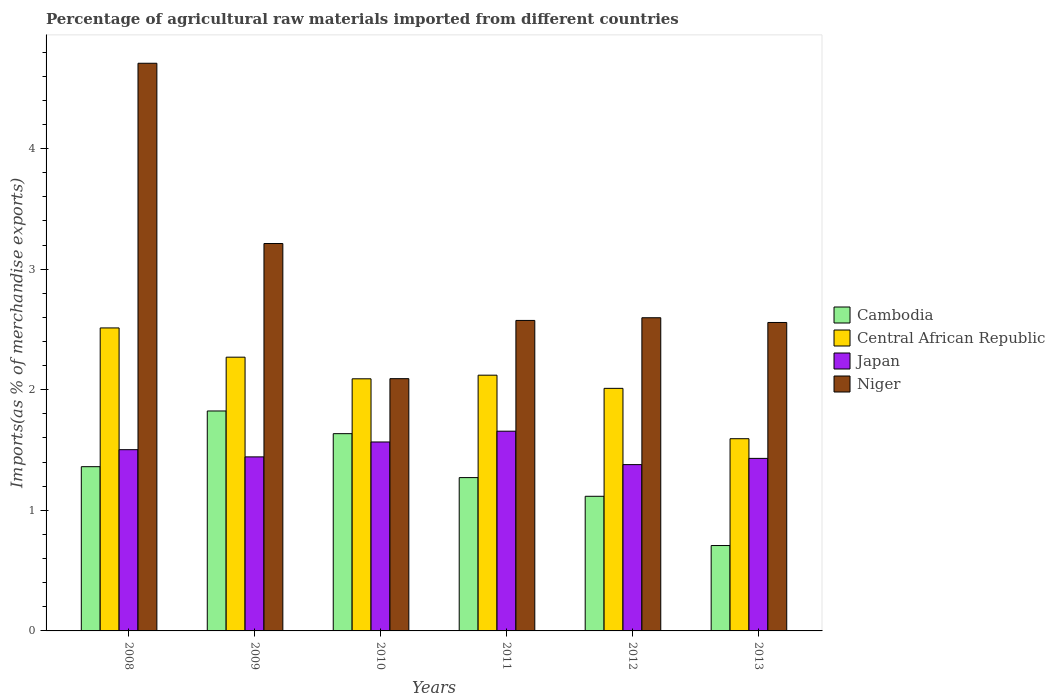How many groups of bars are there?
Provide a short and direct response. 6. Are the number of bars on each tick of the X-axis equal?
Give a very brief answer. Yes. How many bars are there on the 4th tick from the left?
Make the answer very short. 4. In how many cases, is the number of bars for a given year not equal to the number of legend labels?
Provide a short and direct response. 0. What is the percentage of imports to different countries in Cambodia in 2013?
Provide a succinct answer. 0.71. Across all years, what is the maximum percentage of imports to different countries in Central African Republic?
Offer a terse response. 2.51. Across all years, what is the minimum percentage of imports to different countries in Cambodia?
Offer a very short reply. 0.71. In which year was the percentage of imports to different countries in Cambodia maximum?
Offer a terse response. 2009. In which year was the percentage of imports to different countries in Japan minimum?
Keep it short and to the point. 2012. What is the total percentage of imports to different countries in Japan in the graph?
Offer a terse response. 8.98. What is the difference between the percentage of imports to different countries in Japan in 2009 and that in 2011?
Offer a very short reply. -0.21. What is the difference between the percentage of imports to different countries in Niger in 2010 and the percentage of imports to different countries in Central African Republic in 2009?
Your answer should be compact. -0.18. What is the average percentage of imports to different countries in Niger per year?
Keep it short and to the point. 2.96. In the year 2009, what is the difference between the percentage of imports to different countries in Cambodia and percentage of imports to different countries in Japan?
Offer a very short reply. 0.38. In how many years, is the percentage of imports to different countries in Central African Republic greater than 3.8 %?
Ensure brevity in your answer.  0. What is the ratio of the percentage of imports to different countries in Central African Republic in 2010 to that in 2011?
Your answer should be very brief. 0.99. Is the difference between the percentage of imports to different countries in Cambodia in 2010 and 2011 greater than the difference between the percentage of imports to different countries in Japan in 2010 and 2011?
Offer a very short reply. Yes. What is the difference between the highest and the second highest percentage of imports to different countries in Central African Republic?
Your response must be concise. 0.24. What is the difference between the highest and the lowest percentage of imports to different countries in Japan?
Give a very brief answer. 0.28. What does the 2nd bar from the left in 2009 represents?
Offer a very short reply. Central African Republic. Is it the case that in every year, the sum of the percentage of imports to different countries in Niger and percentage of imports to different countries in Japan is greater than the percentage of imports to different countries in Cambodia?
Your answer should be compact. Yes. What is the difference between two consecutive major ticks on the Y-axis?
Ensure brevity in your answer.  1. Are the values on the major ticks of Y-axis written in scientific E-notation?
Provide a short and direct response. No. How are the legend labels stacked?
Your response must be concise. Vertical. What is the title of the graph?
Make the answer very short. Percentage of agricultural raw materials imported from different countries. Does "Micronesia" appear as one of the legend labels in the graph?
Your answer should be very brief. No. What is the label or title of the Y-axis?
Offer a very short reply. Imports(as % of merchandise exports). What is the Imports(as % of merchandise exports) of Cambodia in 2008?
Provide a succinct answer. 1.36. What is the Imports(as % of merchandise exports) of Central African Republic in 2008?
Give a very brief answer. 2.51. What is the Imports(as % of merchandise exports) of Japan in 2008?
Your response must be concise. 1.5. What is the Imports(as % of merchandise exports) of Niger in 2008?
Provide a short and direct response. 4.71. What is the Imports(as % of merchandise exports) in Cambodia in 2009?
Ensure brevity in your answer.  1.82. What is the Imports(as % of merchandise exports) of Central African Republic in 2009?
Offer a very short reply. 2.27. What is the Imports(as % of merchandise exports) of Japan in 2009?
Your answer should be compact. 1.44. What is the Imports(as % of merchandise exports) of Niger in 2009?
Provide a short and direct response. 3.21. What is the Imports(as % of merchandise exports) of Cambodia in 2010?
Ensure brevity in your answer.  1.64. What is the Imports(as % of merchandise exports) of Central African Republic in 2010?
Keep it short and to the point. 2.09. What is the Imports(as % of merchandise exports) of Japan in 2010?
Keep it short and to the point. 1.57. What is the Imports(as % of merchandise exports) in Niger in 2010?
Offer a terse response. 2.09. What is the Imports(as % of merchandise exports) of Cambodia in 2011?
Provide a short and direct response. 1.27. What is the Imports(as % of merchandise exports) in Central African Republic in 2011?
Make the answer very short. 2.12. What is the Imports(as % of merchandise exports) in Japan in 2011?
Your answer should be very brief. 1.66. What is the Imports(as % of merchandise exports) of Niger in 2011?
Provide a succinct answer. 2.57. What is the Imports(as % of merchandise exports) in Cambodia in 2012?
Make the answer very short. 1.12. What is the Imports(as % of merchandise exports) in Central African Republic in 2012?
Your response must be concise. 2.01. What is the Imports(as % of merchandise exports) in Japan in 2012?
Your response must be concise. 1.38. What is the Imports(as % of merchandise exports) of Niger in 2012?
Your answer should be very brief. 2.6. What is the Imports(as % of merchandise exports) in Cambodia in 2013?
Your answer should be very brief. 0.71. What is the Imports(as % of merchandise exports) of Central African Republic in 2013?
Give a very brief answer. 1.59. What is the Imports(as % of merchandise exports) in Japan in 2013?
Provide a succinct answer. 1.43. What is the Imports(as % of merchandise exports) in Niger in 2013?
Offer a terse response. 2.56. Across all years, what is the maximum Imports(as % of merchandise exports) of Cambodia?
Provide a short and direct response. 1.82. Across all years, what is the maximum Imports(as % of merchandise exports) in Central African Republic?
Ensure brevity in your answer.  2.51. Across all years, what is the maximum Imports(as % of merchandise exports) of Japan?
Provide a succinct answer. 1.66. Across all years, what is the maximum Imports(as % of merchandise exports) in Niger?
Ensure brevity in your answer.  4.71. Across all years, what is the minimum Imports(as % of merchandise exports) in Cambodia?
Ensure brevity in your answer.  0.71. Across all years, what is the minimum Imports(as % of merchandise exports) in Central African Republic?
Provide a succinct answer. 1.59. Across all years, what is the minimum Imports(as % of merchandise exports) in Japan?
Keep it short and to the point. 1.38. Across all years, what is the minimum Imports(as % of merchandise exports) of Niger?
Provide a short and direct response. 2.09. What is the total Imports(as % of merchandise exports) in Cambodia in the graph?
Your answer should be very brief. 7.92. What is the total Imports(as % of merchandise exports) of Central African Republic in the graph?
Your answer should be compact. 12.6. What is the total Imports(as % of merchandise exports) in Japan in the graph?
Offer a terse response. 8.98. What is the total Imports(as % of merchandise exports) in Niger in the graph?
Provide a short and direct response. 17.74. What is the difference between the Imports(as % of merchandise exports) in Cambodia in 2008 and that in 2009?
Ensure brevity in your answer.  -0.46. What is the difference between the Imports(as % of merchandise exports) in Central African Republic in 2008 and that in 2009?
Your answer should be very brief. 0.24. What is the difference between the Imports(as % of merchandise exports) of Japan in 2008 and that in 2009?
Ensure brevity in your answer.  0.06. What is the difference between the Imports(as % of merchandise exports) in Niger in 2008 and that in 2009?
Offer a terse response. 1.49. What is the difference between the Imports(as % of merchandise exports) of Cambodia in 2008 and that in 2010?
Your answer should be compact. -0.27. What is the difference between the Imports(as % of merchandise exports) in Central African Republic in 2008 and that in 2010?
Offer a terse response. 0.42. What is the difference between the Imports(as % of merchandise exports) of Japan in 2008 and that in 2010?
Provide a succinct answer. -0.06. What is the difference between the Imports(as % of merchandise exports) of Niger in 2008 and that in 2010?
Your answer should be very brief. 2.62. What is the difference between the Imports(as % of merchandise exports) of Cambodia in 2008 and that in 2011?
Your answer should be compact. 0.09. What is the difference between the Imports(as % of merchandise exports) in Central African Republic in 2008 and that in 2011?
Make the answer very short. 0.39. What is the difference between the Imports(as % of merchandise exports) in Japan in 2008 and that in 2011?
Ensure brevity in your answer.  -0.15. What is the difference between the Imports(as % of merchandise exports) in Niger in 2008 and that in 2011?
Your response must be concise. 2.13. What is the difference between the Imports(as % of merchandise exports) of Cambodia in 2008 and that in 2012?
Make the answer very short. 0.25. What is the difference between the Imports(as % of merchandise exports) in Central African Republic in 2008 and that in 2012?
Give a very brief answer. 0.5. What is the difference between the Imports(as % of merchandise exports) of Japan in 2008 and that in 2012?
Your answer should be very brief. 0.12. What is the difference between the Imports(as % of merchandise exports) in Niger in 2008 and that in 2012?
Provide a short and direct response. 2.11. What is the difference between the Imports(as % of merchandise exports) in Cambodia in 2008 and that in 2013?
Your response must be concise. 0.65. What is the difference between the Imports(as % of merchandise exports) of Central African Republic in 2008 and that in 2013?
Provide a succinct answer. 0.92. What is the difference between the Imports(as % of merchandise exports) in Japan in 2008 and that in 2013?
Your answer should be very brief. 0.07. What is the difference between the Imports(as % of merchandise exports) of Niger in 2008 and that in 2013?
Provide a succinct answer. 2.15. What is the difference between the Imports(as % of merchandise exports) of Cambodia in 2009 and that in 2010?
Offer a very short reply. 0.19. What is the difference between the Imports(as % of merchandise exports) in Central African Republic in 2009 and that in 2010?
Keep it short and to the point. 0.18. What is the difference between the Imports(as % of merchandise exports) in Japan in 2009 and that in 2010?
Ensure brevity in your answer.  -0.12. What is the difference between the Imports(as % of merchandise exports) of Niger in 2009 and that in 2010?
Ensure brevity in your answer.  1.12. What is the difference between the Imports(as % of merchandise exports) of Cambodia in 2009 and that in 2011?
Your answer should be compact. 0.55. What is the difference between the Imports(as % of merchandise exports) of Central African Republic in 2009 and that in 2011?
Provide a succinct answer. 0.15. What is the difference between the Imports(as % of merchandise exports) in Japan in 2009 and that in 2011?
Provide a succinct answer. -0.21. What is the difference between the Imports(as % of merchandise exports) in Niger in 2009 and that in 2011?
Offer a very short reply. 0.64. What is the difference between the Imports(as % of merchandise exports) of Cambodia in 2009 and that in 2012?
Provide a short and direct response. 0.71. What is the difference between the Imports(as % of merchandise exports) in Central African Republic in 2009 and that in 2012?
Offer a terse response. 0.26. What is the difference between the Imports(as % of merchandise exports) in Japan in 2009 and that in 2012?
Your answer should be compact. 0.06. What is the difference between the Imports(as % of merchandise exports) in Niger in 2009 and that in 2012?
Provide a succinct answer. 0.62. What is the difference between the Imports(as % of merchandise exports) of Cambodia in 2009 and that in 2013?
Your answer should be compact. 1.12. What is the difference between the Imports(as % of merchandise exports) of Central African Republic in 2009 and that in 2013?
Your answer should be compact. 0.68. What is the difference between the Imports(as % of merchandise exports) in Japan in 2009 and that in 2013?
Your answer should be compact. 0.01. What is the difference between the Imports(as % of merchandise exports) of Niger in 2009 and that in 2013?
Offer a very short reply. 0.65. What is the difference between the Imports(as % of merchandise exports) in Cambodia in 2010 and that in 2011?
Keep it short and to the point. 0.36. What is the difference between the Imports(as % of merchandise exports) in Central African Republic in 2010 and that in 2011?
Provide a short and direct response. -0.03. What is the difference between the Imports(as % of merchandise exports) of Japan in 2010 and that in 2011?
Your answer should be compact. -0.09. What is the difference between the Imports(as % of merchandise exports) in Niger in 2010 and that in 2011?
Offer a terse response. -0.48. What is the difference between the Imports(as % of merchandise exports) in Cambodia in 2010 and that in 2012?
Give a very brief answer. 0.52. What is the difference between the Imports(as % of merchandise exports) of Central African Republic in 2010 and that in 2012?
Offer a very short reply. 0.08. What is the difference between the Imports(as % of merchandise exports) of Japan in 2010 and that in 2012?
Your response must be concise. 0.19. What is the difference between the Imports(as % of merchandise exports) of Niger in 2010 and that in 2012?
Make the answer very short. -0.51. What is the difference between the Imports(as % of merchandise exports) in Cambodia in 2010 and that in 2013?
Offer a terse response. 0.93. What is the difference between the Imports(as % of merchandise exports) in Central African Republic in 2010 and that in 2013?
Ensure brevity in your answer.  0.5. What is the difference between the Imports(as % of merchandise exports) of Japan in 2010 and that in 2013?
Provide a succinct answer. 0.14. What is the difference between the Imports(as % of merchandise exports) of Niger in 2010 and that in 2013?
Ensure brevity in your answer.  -0.47. What is the difference between the Imports(as % of merchandise exports) of Cambodia in 2011 and that in 2012?
Your answer should be compact. 0.15. What is the difference between the Imports(as % of merchandise exports) in Central African Republic in 2011 and that in 2012?
Your answer should be compact. 0.11. What is the difference between the Imports(as % of merchandise exports) of Japan in 2011 and that in 2012?
Provide a succinct answer. 0.28. What is the difference between the Imports(as % of merchandise exports) of Niger in 2011 and that in 2012?
Ensure brevity in your answer.  -0.02. What is the difference between the Imports(as % of merchandise exports) in Cambodia in 2011 and that in 2013?
Your answer should be very brief. 0.56. What is the difference between the Imports(as % of merchandise exports) of Central African Republic in 2011 and that in 2013?
Ensure brevity in your answer.  0.53. What is the difference between the Imports(as % of merchandise exports) of Japan in 2011 and that in 2013?
Provide a succinct answer. 0.23. What is the difference between the Imports(as % of merchandise exports) in Niger in 2011 and that in 2013?
Your answer should be very brief. 0.02. What is the difference between the Imports(as % of merchandise exports) of Cambodia in 2012 and that in 2013?
Provide a succinct answer. 0.41. What is the difference between the Imports(as % of merchandise exports) in Central African Republic in 2012 and that in 2013?
Keep it short and to the point. 0.42. What is the difference between the Imports(as % of merchandise exports) of Japan in 2012 and that in 2013?
Ensure brevity in your answer.  -0.05. What is the difference between the Imports(as % of merchandise exports) in Niger in 2012 and that in 2013?
Your response must be concise. 0.04. What is the difference between the Imports(as % of merchandise exports) of Cambodia in 2008 and the Imports(as % of merchandise exports) of Central African Republic in 2009?
Make the answer very short. -0.91. What is the difference between the Imports(as % of merchandise exports) of Cambodia in 2008 and the Imports(as % of merchandise exports) of Japan in 2009?
Your answer should be compact. -0.08. What is the difference between the Imports(as % of merchandise exports) of Cambodia in 2008 and the Imports(as % of merchandise exports) of Niger in 2009?
Offer a terse response. -1.85. What is the difference between the Imports(as % of merchandise exports) of Central African Republic in 2008 and the Imports(as % of merchandise exports) of Japan in 2009?
Your answer should be compact. 1.07. What is the difference between the Imports(as % of merchandise exports) in Central African Republic in 2008 and the Imports(as % of merchandise exports) in Niger in 2009?
Ensure brevity in your answer.  -0.7. What is the difference between the Imports(as % of merchandise exports) of Japan in 2008 and the Imports(as % of merchandise exports) of Niger in 2009?
Give a very brief answer. -1.71. What is the difference between the Imports(as % of merchandise exports) in Cambodia in 2008 and the Imports(as % of merchandise exports) in Central African Republic in 2010?
Ensure brevity in your answer.  -0.73. What is the difference between the Imports(as % of merchandise exports) of Cambodia in 2008 and the Imports(as % of merchandise exports) of Japan in 2010?
Your response must be concise. -0.2. What is the difference between the Imports(as % of merchandise exports) in Cambodia in 2008 and the Imports(as % of merchandise exports) in Niger in 2010?
Your answer should be compact. -0.73. What is the difference between the Imports(as % of merchandise exports) of Central African Republic in 2008 and the Imports(as % of merchandise exports) of Japan in 2010?
Ensure brevity in your answer.  0.95. What is the difference between the Imports(as % of merchandise exports) in Central African Republic in 2008 and the Imports(as % of merchandise exports) in Niger in 2010?
Your response must be concise. 0.42. What is the difference between the Imports(as % of merchandise exports) in Japan in 2008 and the Imports(as % of merchandise exports) in Niger in 2010?
Make the answer very short. -0.59. What is the difference between the Imports(as % of merchandise exports) in Cambodia in 2008 and the Imports(as % of merchandise exports) in Central African Republic in 2011?
Your answer should be very brief. -0.76. What is the difference between the Imports(as % of merchandise exports) of Cambodia in 2008 and the Imports(as % of merchandise exports) of Japan in 2011?
Make the answer very short. -0.29. What is the difference between the Imports(as % of merchandise exports) in Cambodia in 2008 and the Imports(as % of merchandise exports) in Niger in 2011?
Provide a succinct answer. -1.21. What is the difference between the Imports(as % of merchandise exports) in Central African Republic in 2008 and the Imports(as % of merchandise exports) in Japan in 2011?
Offer a terse response. 0.86. What is the difference between the Imports(as % of merchandise exports) of Central African Republic in 2008 and the Imports(as % of merchandise exports) of Niger in 2011?
Ensure brevity in your answer.  -0.06. What is the difference between the Imports(as % of merchandise exports) in Japan in 2008 and the Imports(as % of merchandise exports) in Niger in 2011?
Offer a very short reply. -1.07. What is the difference between the Imports(as % of merchandise exports) in Cambodia in 2008 and the Imports(as % of merchandise exports) in Central African Republic in 2012?
Ensure brevity in your answer.  -0.65. What is the difference between the Imports(as % of merchandise exports) of Cambodia in 2008 and the Imports(as % of merchandise exports) of Japan in 2012?
Provide a succinct answer. -0.02. What is the difference between the Imports(as % of merchandise exports) of Cambodia in 2008 and the Imports(as % of merchandise exports) of Niger in 2012?
Offer a very short reply. -1.23. What is the difference between the Imports(as % of merchandise exports) in Central African Republic in 2008 and the Imports(as % of merchandise exports) in Japan in 2012?
Provide a short and direct response. 1.13. What is the difference between the Imports(as % of merchandise exports) of Central African Republic in 2008 and the Imports(as % of merchandise exports) of Niger in 2012?
Your answer should be compact. -0.08. What is the difference between the Imports(as % of merchandise exports) in Japan in 2008 and the Imports(as % of merchandise exports) in Niger in 2012?
Give a very brief answer. -1.09. What is the difference between the Imports(as % of merchandise exports) in Cambodia in 2008 and the Imports(as % of merchandise exports) in Central African Republic in 2013?
Your response must be concise. -0.23. What is the difference between the Imports(as % of merchandise exports) of Cambodia in 2008 and the Imports(as % of merchandise exports) of Japan in 2013?
Provide a short and direct response. -0.07. What is the difference between the Imports(as % of merchandise exports) in Cambodia in 2008 and the Imports(as % of merchandise exports) in Niger in 2013?
Offer a terse response. -1.2. What is the difference between the Imports(as % of merchandise exports) of Central African Republic in 2008 and the Imports(as % of merchandise exports) of Japan in 2013?
Your response must be concise. 1.08. What is the difference between the Imports(as % of merchandise exports) in Central African Republic in 2008 and the Imports(as % of merchandise exports) in Niger in 2013?
Provide a succinct answer. -0.05. What is the difference between the Imports(as % of merchandise exports) in Japan in 2008 and the Imports(as % of merchandise exports) in Niger in 2013?
Keep it short and to the point. -1.05. What is the difference between the Imports(as % of merchandise exports) in Cambodia in 2009 and the Imports(as % of merchandise exports) in Central African Republic in 2010?
Keep it short and to the point. -0.27. What is the difference between the Imports(as % of merchandise exports) of Cambodia in 2009 and the Imports(as % of merchandise exports) of Japan in 2010?
Provide a succinct answer. 0.26. What is the difference between the Imports(as % of merchandise exports) of Cambodia in 2009 and the Imports(as % of merchandise exports) of Niger in 2010?
Ensure brevity in your answer.  -0.27. What is the difference between the Imports(as % of merchandise exports) in Central African Republic in 2009 and the Imports(as % of merchandise exports) in Japan in 2010?
Your answer should be compact. 0.7. What is the difference between the Imports(as % of merchandise exports) of Central African Republic in 2009 and the Imports(as % of merchandise exports) of Niger in 2010?
Ensure brevity in your answer.  0.18. What is the difference between the Imports(as % of merchandise exports) in Japan in 2009 and the Imports(as % of merchandise exports) in Niger in 2010?
Ensure brevity in your answer.  -0.65. What is the difference between the Imports(as % of merchandise exports) in Cambodia in 2009 and the Imports(as % of merchandise exports) in Central African Republic in 2011?
Keep it short and to the point. -0.3. What is the difference between the Imports(as % of merchandise exports) in Cambodia in 2009 and the Imports(as % of merchandise exports) in Japan in 2011?
Provide a short and direct response. 0.17. What is the difference between the Imports(as % of merchandise exports) in Cambodia in 2009 and the Imports(as % of merchandise exports) in Niger in 2011?
Keep it short and to the point. -0.75. What is the difference between the Imports(as % of merchandise exports) of Central African Republic in 2009 and the Imports(as % of merchandise exports) of Japan in 2011?
Provide a succinct answer. 0.61. What is the difference between the Imports(as % of merchandise exports) in Central African Republic in 2009 and the Imports(as % of merchandise exports) in Niger in 2011?
Your answer should be very brief. -0.3. What is the difference between the Imports(as % of merchandise exports) of Japan in 2009 and the Imports(as % of merchandise exports) of Niger in 2011?
Your answer should be compact. -1.13. What is the difference between the Imports(as % of merchandise exports) of Cambodia in 2009 and the Imports(as % of merchandise exports) of Central African Republic in 2012?
Ensure brevity in your answer.  -0.19. What is the difference between the Imports(as % of merchandise exports) in Cambodia in 2009 and the Imports(as % of merchandise exports) in Japan in 2012?
Provide a short and direct response. 0.44. What is the difference between the Imports(as % of merchandise exports) in Cambodia in 2009 and the Imports(as % of merchandise exports) in Niger in 2012?
Provide a short and direct response. -0.77. What is the difference between the Imports(as % of merchandise exports) of Central African Republic in 2009 and the Imports(as % of merchandise exports) of Japan in 2012?
Ensure brevity in your answer.  0.89. What is the difference between the Imports(as % of merchandise exports) of Central African Republic in 2009 and the Imports(as % of merchandise exports) of Niger in 2012?
Make the answer very short. -0.33. What is the difference between the Imports(as % of merchandise exports) in Japan in 2009 and the Imports(as % of merchandise exports) in Niger in 2012?
Give a very brief answer. -1.15. What is the difference between the Imports(as % of merchandise exports) in Cambodia in 2009 and the Imports(as % of merchandise exports) in Central African Republic in 2013?
Your answer should be compact. 0.23. What is the difference between the Imports(as % of merchandise exports) of Cambodia in 2009 and the Imports(as % of merchandise exports) of Japan in 2013?
Your answer should be very brief. 0.39. What is the difference between the Imports(as % of merchandise exports) in Cambodia in 2009 and the Imports(as % of merchandise exports) in Niger in 2013?
Provide a short and direct response. -0.73. What is the difference between the Imports(as % of merchandise exports) in Central African Republic in 2009 and the Imports(as % of merchandise exports) in Japan in 2013?
Make the answer very short. 0.84. What is the difference between the Imports(as % of merchandise exports) in Central African Republic in 2009 and the Imports(as % of merchandise exports) in Niger in 2013?
Provide a short and direct response. -0.29. What is the difference between the Imports(as % of merchandise exports) of Japan in 2009 and the Imports(as % of merchandise exports) of Niger in 2013?
Give a very brief answer. -1.11. What is the difference between the Imports(as % of merchandise exports) in Cambodia in 2010 and the Imports(as % of merchandise exports) in Central African Republic in 2011?
Provide a short and direct response. -0.48. What is the difference between the Imports(as % of merchandise exports) in Cambodia in 2010 and the Imports(as % of merchandise exports) in Japan in 2011?
Make the answer very short. -0.02. What is the difference between the Imports(as % of merchandise exports) in Cambodia in 2010 and the Imports(as % of merchandise exports) in Niger in 2011?
Provide a succinct answer. -0.94. What is the difference between the Imports(as % of merchandise exports) of Central African Republic in 2010 and the Imports(as % of merchandise exports) of Japan in 2011?
Your answer should be very brief. 0.43. What is the difference between the Imports(as % of merchandise exports) in Central African Republic in 2010 and the Imports(as % of merchandise exports) in Niger in 2011?
Provide a short and direct response. -0.48. What is the difference between the Imports(as % of merchandise exports) of Japan in 2010 and the Imports(as % of merchandise exports) of Niger in 2011?
Offer a very short reply. -1.01. What is the difference between the Imports(as % of merchandise exports) of Cambodia in 2010 and the Imports(as % of merchandise exports) of Central African Republic in 2012?
Make the answer very short. -0.38. What is the difference between the Imports(as % of merchandise exports) of Cambodia in 2010 and the Imports(as % of merchandise exports) of Japan in 2012?
Make the answer very short. 0.26. What is the difference between the Imports(as % of merchandise exports) in Cambodia in 2010 and the Imports(as % of merchandise exports) in Niger in 2012?
Your answer should be compact. -0.96. What is the difference between the Imports(as % of merchandise exports) in Central African Republic in 2010 and the Imports(as % of merchandise exports) in Japan in 2012?
Ensure brevity in your answer.  0.71. What is the difference between the Imports(as % of merchandise exports) of Central African Republic in 2010 and the Imports(as % of merchandise exports) of Niger in 2012?
Keep it short and to the point. -0.51. What is the difference between the Imports(as % of merchandise exports) of Japan in 2010 and the Imports(as % of merchandise exports) of Niger in 2012?
Provide a succinct answer. -1.03. What is the difference between the Imports(as % of merchandise exports) of Cambodia in 2010 and the Imports(as % of merchandise exports) of Central African Republic in 2013?
Keep it short and to the point. 0.04. What is the difference between the Imports(as % of merchandise exports) of Cambodia in 2010 and the Imports(as % of merchandise exports) of Japan in 2013?
Ensure brevity in your answer.  0.2. What is the difference between the Imports(as % of merchandise exports) of Cambodia in 2010 and the Imports(as % of merchandise exports) of Niger in 2013?
Your answer should be compact. -0.92. What is the difference between the Imports(as % of merchandise exports) of Central African Republic in 2010 and the Imports(as % of merchandise exports) of Japan in 2013?
Provide a succinct answer. 0.66. What is the difference between the Imports(as % of merchandise exports) of Central African Republic in 2010 and the Imports(as % of merchandise exports) of Niger in 2013?
Ensure brevity in your answer.  -0.47. What is the difference between the Imports(as % of merchandise exports) in Japan in 2010 and the Imports(as % of merchandise exports) in Niger in 2013?
Your response must be concise. -0.99. What is the difference between the Imports(as % of merchandise exports) in Cambodia in 2011 and the Imports(as % of merchandise exports) in Central African Republic in 2012?
Make the answer very short. -0.74. What is the difference between the Imports(as % of merchandise exports) in Cambodia in 2011 and the Imports(as % of merchandise exports) in Japan in 2012?
Keep it short and to the point. -0.11. What is the difference between the Imports(as % of merchandise exports) of Cambodia in 2011 and the Imports(as % of merchandise exports) of Niger in 2012?
Ensure brevity in your answer.  -1.33. What is the difference between the Imports(as % of merchandise exports) in Central African Republic in 2011 and the Imports(as % of merchandise exports) in Japan in 2012?
Give a very brief answer. 0.74. What is the difference between the Imports(as % of merchandise exports) in Central African Republic in 2011 and the Imports(as % of merchandise exports) in Niger in 2012?
Your answer should be compact. -0.48. What is the difference between the Imports(as % of merchandise exports) in Japan in 2011 and the Imports(as % of merchandise exports) in Niger in 2012?
Make the answer very short. -0.94. What is the difference between the Imports(as % of merchandise exports) in Cambodia in 2011 and the Imports(as % of merchandise exports) in Central African Republic in 2013?
Offer a very short reply. -0.32. What is the difference between the Imports(as % of merchandise exports) of Cambodia in 2011 and the Imports(as % of merchandise exports) of Japan in 2013?
Ensure brevity in your answer.  -0.16. What is the difference between the Imports(as % of merchandise exports) of Cambodia in 2011 and the Imports(as % of merchandise exports) of Niger in 2013?
Provide a succinct answer. -1.29. What is the difference between the Imports(as % of merchandise exports) in Central African Republic in 2011 and the Imports(as % of merchandise exports) in Japan in 2013?
Give a very brief answer. 0.69. What is the difference between the Imports(as % of merchandise exports) of Central African Republic in 2011 and the Imports(as % of merchandise exports) of Niger in 2013?
Provide a succinct answer. -0.44. What is the difference between the Imports(as % of merchandise exports) in Japan in 2011 and the Imports(as % of merchandise exports) in Niger in 2013?
Offer a very short reply. -0.9. What is the difference between the Imports(as % of merchandise exports) of Cambodia in 2012 and the Imports(as % of merchandise exports) of Central African Republic in 2013?
Give a very brief answer. -0.48. What is the difference between the Imports(as % of merchandise exports) of Cambodia in 2012 and the Imports(as % of merchandise exports) of Japan in 2013?
Your answer should be compact. -0.31. What is the difference between the Imports(as % of merchandise exports) in Cambodia in 2012 and the Imports(as % of merchandise exports) in Niger in 2013?
Your answer should be compact. -1.44. What is the difference between the Imports(as % of merchandise exports) in Central African Republic in 2012 and the Imports(as % of merchandise exports) in Japan in 2013?
Provide a short and direct response. 0.58. What is the difference between the Imports(as % of merchandise exports) in Central African Republic in 2012 and the Imports(as % of merchandise exports) in Niger in 2013?
Give a very brief answer. -0.55. What is the difference between the Imports(as % of merchandise exports) in Japan in 2012 and the Imports(as % of merchandise exports) in Niger in 2013?
Your answer should be very brief. -1.18. What is the average Imports(as % of merchandise exports) in Cambodia per year?
Make the answer very short. 1.32. What is the average Imports(as % of merchandise exports) in Central African Republic per year?
Ensure brevity in your answer.  2.1. What is the average Imports(as % of merchandise exports) in Japan per year?
Provide a short and direct response. 1.5. What is the average Imports(as % of merchandise exports) of Niger per year?
Provide a succinct answer. 2.96. In the year 2008, what is the difference between the Imports(as % of merchandise exports) in Cambodia and Imports(as % of merchandise exports) in Central African Republic?
Give a very brief answer. -1.15. In the year 2008, what is the difference between the Imports(as % of merchandise exports) in Cambodia and Imports(as % of merchandise exports) in Japan?
Provide a short and direct response. -0.14. In the year 2008, what is the difference between the Imports(as % of merchandise exports) in Cambodia and Imports(as % of merchandise exports) in Niger?
Your response must be concise. -3.35. In the year 2008, what is the difference between the Imports(as % of merchandise exports) of Central African Republic and Imports(as % of merchandise exports) of Japan?
Offer a very short reply. 1.01. In the year 2008, what is the difference between the Imports(as % of merchandise exports) in Central African Republic and Imports(as % of merchandise exports) in Niger?
Offer a very short reply. -2.19. In the year 2008, what is the difference between the Imports(as % of merchandise exports) in Japan and Imports(as % of merchandise exports) in Niger?
Provide a succinct answer. -3.2. In the year 2009, what is the difference between the Imports(as % of merchandise exports) of Cambodia and Imports(as % of merchandise exports) of Central African Republic?
Your answer should be very brief. -0.45. In the year 2009, what is the difference between the Imports(as % of merchandise exports) of Cambodia and Imports(as % of merchandise exports) of Japan?
Your answer should be compact. 0.38. In the year 2009, what is the difference between the Imports(as % of merchandise exports) of Cambodia and Imports(as % of merchandise exports) of Niger?
Provide a succinct answer. -1.39. In the year 2009, what is the difference between the Imports(as % of merchandise exports) in Central African Republic and Imports(as % of merchandise exports) in Japan?
Keep it short and to the point. 0.83. In the year 2009, what is the difference between the Imports(as % of merchandise exports) in Central African Republic and Imports(as % of merchandise exports) in Niger?
Provide a short and direct response. -0.94. In the year 2009, what is the difference between the Imports(as % of merchandise exports) of Japan and Imports(as % of merchandise exports) of Niger?
Provide a succinct answer. -1.77. In the year 2010, what is the difference between the Imports(as % of merchandise exports) of Cambodia and Imports(as % of merchandise exports) of Central African Republic?
Provide a succinct answer. -0.45. In the year 2010, what is the difference between the Imports(as % of merchandise exports) in Cambodia and Imports(as % of merchandise exports) in Japan?
Provide a short and direct response. 0.07. In the year 2010, what is the difference between the Imports(as % of merchandise exports) in Cambodia and Imports(as % of merchandise exports) in Niger?
Keep it short and to the point. -0.46. In the year 2010, what is the difference between the Imports(as % of merchandise exports) in Central African Republic and Imports(as % of merchandise exports) in Japan?
Offer a terse response. 0.52. In the year 2010, what is the difference between the Imports(as % of merchandise exports) in Central African Republic and Imports(as % of merchandise exports) in Niger?
Keep it short and to the point. -0. In the year 2010, what is the difference between the Imports(as % of merchandise exports) of Japan and Imports(as % of merchandise exports) of Niger?
Offer a very short reply. -0.53. In the year 2011, what is the difference between the Imports(as % of merchandise exports) in Cambodia and Imports(as % of merchandise exports) in Central African Republic?
Offer a terse response. -0.85. In the year 2011, what is the difference between the Imports(as % of merchandise exports) in Cambodia and Imports(as % of merchandise exports) in Japan?
Your answer should be very brief. -0.38. In the year 2011, what is the difference between the Imports(as % of merchandise exports) of Cambodia and Imports(as % of merchandise exports) of Niger?
Your answer should be very brief. -1.3. In the year 2011, what is the difference between the Imports(as % of merchandise exports) of Central African Republic and Imports(as % of merchandise exports) of Japan?
Offer a very short reply. 0.46. In the year 2011, what is the difference between the Imports(as % of merchandise exports) of Central African Republic and Imports(as % of merchandise exports) of Niger?
Make the answer very short. -0.45. In the year 2011, what is the difference between the Imports(as % of merchandise exports) of Japan and Imports(as % of merchandise exports) of Niger?
Provide a succinct answer. -0.92. In the year 2012, what is the difference between the Imports(as % of merchandise exports) of Cambodia and Imports(as % of merchandise exports) of Central African Republic?
Make the answer very short. -0.9. In the year 2012, what is the difference between the Imports(as % of merchandise exports) in Cambodia and Imports(as % of merchandise exports) in Japan?
Your response must be concise. -0.26. In the year 2012, what is the difference between the Imports(as % of merchandise exports) of Cambodia and Imports(as % of merchandise exports) of Niger?
Make the answer very short. -1.48. In the year 2012, what is the difference between the Imports(as % of merchandise exports) of Central African Republic and Imports(as % of merchandise exports) of Japan?
Your answer should be very brief. 0.63. In the year 2012, what is the difference between the Imports(as % of merchandise exports) of Central African Republic and Imports(as % of merchandise exports) of Niger?
Your answer should be compact. -0.59. In the year 2012, what is the difference between the Imports(as % of merchandise exports) in Japan and Imports(as % of merchandise exports) in Niger?
Provide a short and direct response. -1.22. In the year 2013, what is the difference between the Imports(as % of merchandise exports) of Cambodia and Imports(as % of merchandise exports) of Central African Republic?
Your answer should be compact. -0.89. In the year 2013, what is the difference between the Imports(as % of merchandise exports) of Cambodia and Imports(as % of merchandise exports) of Japan?
Your answer should be compact. -0.72. In the year 2013, what is the difference between the Imports(as % of merchandise exports) in Cambodia and Imports(as % of merchandise exports) in Niger?
Offer a very short reply. -1.85. In the year 2013, what is the difference between the Imports(as % of merchandise exports) of Central African Republic and Imports(as % of merchandise exports) of Japan?
Your answer should be very brief. 0.16. In the year 2013, what is the difference between the Imports(as % of merchandise exports) of Central African Republic and Imports(as % of merchandise exports) of Niger?
Provide a short and direct response. -0.96. In the year 2013, what is the difference between the Imports(as % of merchandise exports) of Japan and Imports(as % of merchandise exports) of Niger?
Keep it short and to the point. -1.13. What is the ratio of the Imports(as % of merchandise exports) of Cambodia in 2008 to that in 2009?
Your response must be concise. 0.75. What is the ratio of the Imports(as % of merchandise exports) in Central African Republic in 2008 to that in 2009?
Your response must be concise. 1.11. What is the ratio of the Imports(as % of merchandise exports) in Japan in 2008 to that in 2009?
Keep it short and to the point. 1.04. What is the ratio of the Imports(as % of merchandise exports) of Niger in 2008 to that in 2009?
Provide a short and direct response. 1.47. What is the ratio of the Imports(as % of merchandise exports) in Cambodia in 2008 to that in 2010?
Your answer should be very brief. 0.83. What is the ratio of the Imports(as % of merchandise exports) in Central African Republic in 2008 to that in 2010?
Ensure brevity in your answer.  1.2. What is the ratio of the Imports(as % of merchandise exports) in Japan in 2008 to that in 2010?
Provide a short and direct response. 0.96. What is the ratio of the Imports(as % of merchandise exports) in Niger in 2008 to that in 2010?
Your answer should be very brief. 2.25. What is the ratio of the Imports(as % of merchandise exports) of Cambodia in 2008 to that in 2011?
Ensure brevity in your answer.  1.07. What is the ratio of the Imports(as % of merchandise exports) in Central African Republic in 2008 to that in 2011?
Provide a succinct answer. 1.18. What is the ratio of the Imports(as % of merchandise exports) of Japan in 2008 to that in 2011?
Your answer should be very brief. 0.91. What is the ratio of the Imports(as % of merchandise exports) of Niger in 2008 to that in 2011?
Keep it short and to the point. 1.83. What is the ratio of the Imports(as % of merchandise exports) of Cambodia in 2008 to that in 2012?
Make the answer very short. 1.22. What is the ratio of the Imports(as % of merchandise exports) in Central African Republic in 2008 to that in 2012?
Your answer should be compact. 1.25. What is the ratio of the Imports(as % of merchandise exports) of Japan in 2008 to that in 2012?
Your answer should be compact. 1.09. What is the ratio of the Imports(as % of merchandise exports) in Niger in 2008 to that in 2012?
Your response must be concise. 1.81. What is the ratio of the Imports(as % of merchandise exports) in Cambodia in 2008 to that in 2013?
Make the answer very short. 1.92. What is the ratio of the Imports(as % of merchandise exports) in Central African Republic in 2008 to that in 2013?
Your answer should be compact. 1.58. What is the ratio of the Imports(as % of merchandise exports) in Japan in 2008 to that in 2013?
Ensure brevity in your answer.  1.05. What is the ratio of the Imports(as % of merchandise exports) of Niger in 2008 to that in 2013?
Your response must be concise. 1.84. What is the ratio of the Imports(as % of merchandise exports) in Cambodia in 2009 to that in 2010?
Give a very brief answer. 1.11. What is the ratio of the Imports(as % of merchandise exports) in Central African Republic in 2009 to that in 2010?
Offer a terse response. 1.09. What is the ratio of the Imports(as % of merchandise exports) in Japan in 2009 to that in 2010?
Provide a succinct answer. 0.92. What is the ratio of the Imports(as % of merchandise exports) of Niger in 2009 to that in 2010?
Your answer should be very brief. 1.54. What is the ratio of the Imports(as % of merchandise exports) of Cambodia in 2009 to that in 2011?
Give a very brief answer. 1.43. What is the ratio of the Imports(as % of merchandise exports) of Central African Republic in 2009 to that in 2011?
Your response must be concise. 1.07. What is the ratio of the Imports(as % of merchandise exports) in Japan in 2009 to that in 2011?
Your response must be concise. 0.87. What is the ratio of the Imports(as % of merchandise exports) of Niger in 2009 to that in 2011?
Offer a very short reply. 1.25. What is the ratio of the Imports(as % of merchandise exports) in Cambodia in 2009 to that in 2012?
Keep it short and to the point. 1.63. What is the ratio of the Imports(as % of merchandise exports) in Central African Republic in 2009 to that in 2012?
Make the answer very short. 1.13. What is the ratio of the Imports(as % of merchandise exports) in Japan in 2009 to that in 2012?
Provide a succinct answer. 1.05. What is the ratio of the Imports(as % of merchandise exports) in Niger in 2009 to that in 2012?
Make the answer very short. 1.24. What is the ratio of the Imports(as % of merchandise exports) in Cambodia in 2009 to that in 2013?
Keep it short and to the point. 2.58. What is the ratio of the Imports(as % of merchandise exports) in Central African Republic in 2009 to that in 2013?
Offer a very short reply. 1.42. What is the ratio of the Imports(as % of merchandise exports) in Japan in 2009 to that in 2013?
Offer a terse response. 1.01. What is the ratio of the Imports(as % of merchandise exports) in Niger in 2009 to that in 2013?
Your answer should be very brief. 1.26. What is the ratio of the Imports(as % of merchandise exports) of Cambodia in 2010 to that in 2011?
Offer a very short reply. 1.29. What is the ratio of the Imports(as % of merchandise exports) in Central African Republic in 2010 to that in 2011?
Give a very brief answer. 0.99. What is the ratio of the Imports(as % of merchandise exports) in Japan in 2010 to that in 2011?
Make the answer very short. 0.95. What is the ratio of the Imports(as % of merchandise exports) in Niger in 2010 to that in 2011?
Ensure brevity in your answer.  0.81. What is the ratio of the Imports(as % of merchandise exports) in Cambodia in 2010 to that in 2012?
Keep it short and to the point. 1.47. What is the ratio of the Imports(as % of merchandise exports) in Central African Republic in 2010 to that in 2012?
Provide a short and direct response. 1.04. What is the ratio of the Imports(as % of merchandise exports) of Japan in 2010 to that in 2012?
Provide a succinct answer. 1.14. What is the ratio of the Imports(as % of merchandise exports) of Niger in 2010 to that in 2012?
Offer a terse response. 0.81. What is the ratio of the Imports(as % of merchandise exports) in Cambodia in 2010 to that in 2013?
Ensure brevity in your answer.  2.31. What is the ratio of the Imports(as % of merchandise exports) of Central African Republic in 2010 to that in 2013?
Your answer should be compact. 1.31. What is the ratio of the Imports(as % of merchandise exports) in Japan in 2010 to that in 2013?
Ensure brevity in your answer.  1.09. What is the ratio of the Imports(as % of merchandise exports) of Niger in 2010 to that in 2013?
Keep it short and to the point. 0.82. What is the ratio of the Imports(as % of merchandise exports) in Cambodia in 2011 to that in 2012?
Provide a short and direct response. 1.14. What is the ratio of the Imports(as % of merchandise exports) of Central African Republic in 2011 to that in 2012?
Offer a terse response. 1.05. What is the ratio of the Imports(as % of merchandise exports) in Japan in 2011 to that in 2012?
Keep it short and to the point. 1.2. What is the ratio of the Imports(as % of merchandise exports) of Cambodia in 2011 to that in 2013?
Make the answer very short. 1.8. What is the ratio of the Imports(as % of merchandise exports) of Central African Republic in 2011 to that in 2013?
Offer a terse response. 1.33. What is the ratio of the Imports(as % of merchandise exports) of Japan in 2011 to that in 2013?
Make the answer very short. 1.16. What is the ratio of the Imports(as % of merchandise exports) in Niger in 2011 to that in 2013?
Your response must be concise. 1.01. What is the ratio of the Imports(as % of merchandise exports) of Cambodia in 2012 to that in 2013?
Your response must be concise. 1.58. What is the ratio of the Imports(as % of merchandise exports) in Central African Republic in 2012 to that in 2013?
Keep it short and to the point. 1.26. What is the ratio of the Imports(as % of merchandise exports) in Japan in 2012 to that in 2013?
Provide a succinct answer. 0.96. What is the ratio of the Imports(as % of merchandise exports) in Niger in 2012 to that in 2013?
Provide a succinct answer. 1.02. What is the difference between the highest and the second highest Imports(as % of merchandise exports) in Cambodia?
Your answer should be very brief. 0.19. What is the difference between the highest and the second highest Imports(as % of merchandise exports) of Central African Republic?
Make the answer very short. 0.24. What is the difference between the highest and the second highest Imports(as % of merchandise exports) of Japan?
Make the answer very short. 0.09. What is the difference between the highest and the second highest Imports(as % of merchandise exports) of Niger?
Make the answer very short. 1.49. What is the difference between the highest and the lowest Imports(as % of merchandise exports) in Cambodia?
Keep it short and to the point. 1.12. What is the difference between the highest and the lowest Imports(as % of merchandise exports) in Central African Republic?
Keep it short and to the point. 0.92. What is the difference between the highest and the lowest Imports(as % of merchandise exports) of Japan?
Keep it short and to the point. 0.28. What is the difference between the highest and the lowest Imports(as % of merchandise exports) of Niger?
Keep it short and to the point. 2.62. 